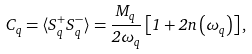Convert formula to latex. <formula><loc_0><loc_0><loc_500><loc_500>C _ { q } = \langle S _ { q } ^ { + } S _ { q } ^ { - } \rangle = \frac { M _ { q } } { 2 \omega _ { q } } \left [ 1 + 2 n \left ( \omega _ { q } \right ) \right ] ,</formula> 